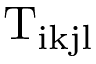<formula> <loc_0><loc_0><loc_500><loc_500>T _ { i k j l }</formula> 